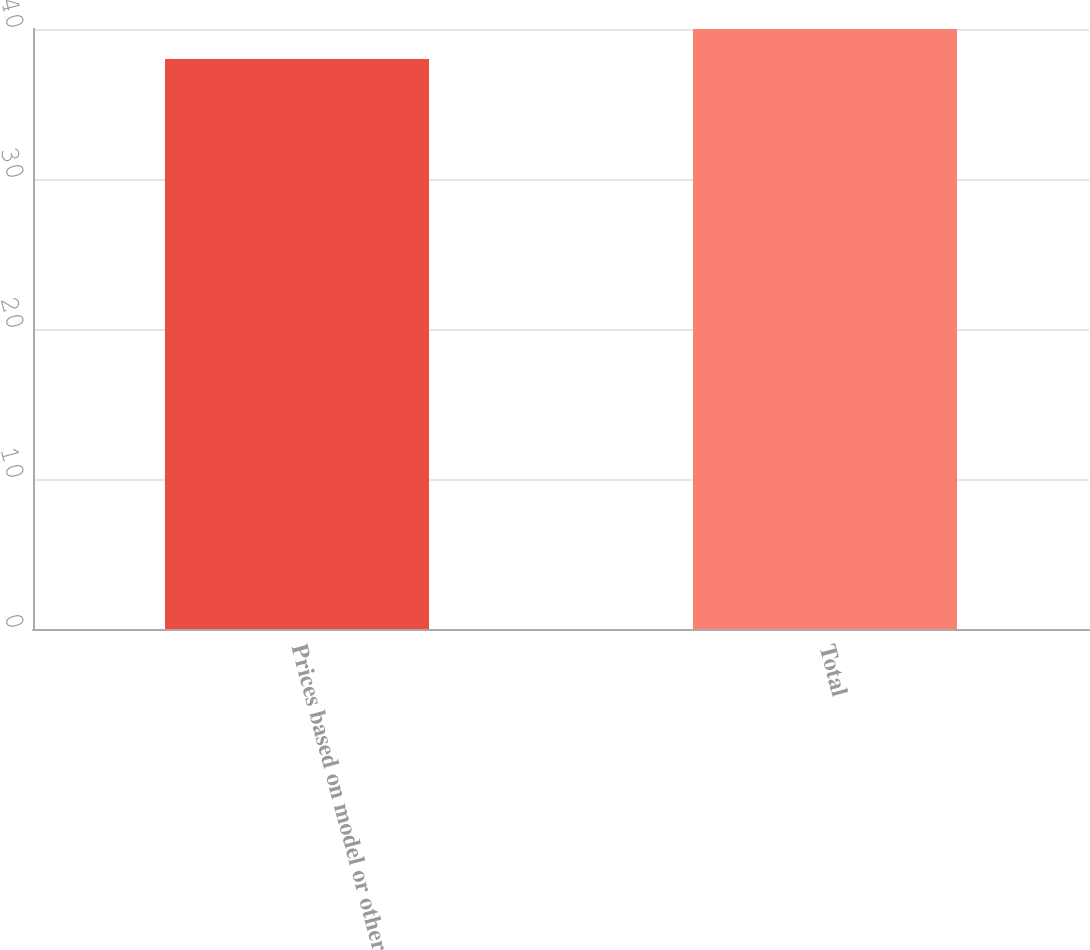Convert chart to OTSL. <chart><loc_0><loc_0><loc_500><loc_500><bar_chart><fcel>Prices based on model or other<fcel>Total<nl><fcel>38<fcel>40<nl></chart> 